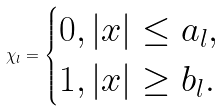Convert formula to latex. <formula><loc_0><loc_0><loc_500><loc_500>\chi _ { l } = \begin{cases} 0 , | x | \leq a _ { l } , \\ 1 , | x | \geq b _ { l } . \end{cases}</formula> 